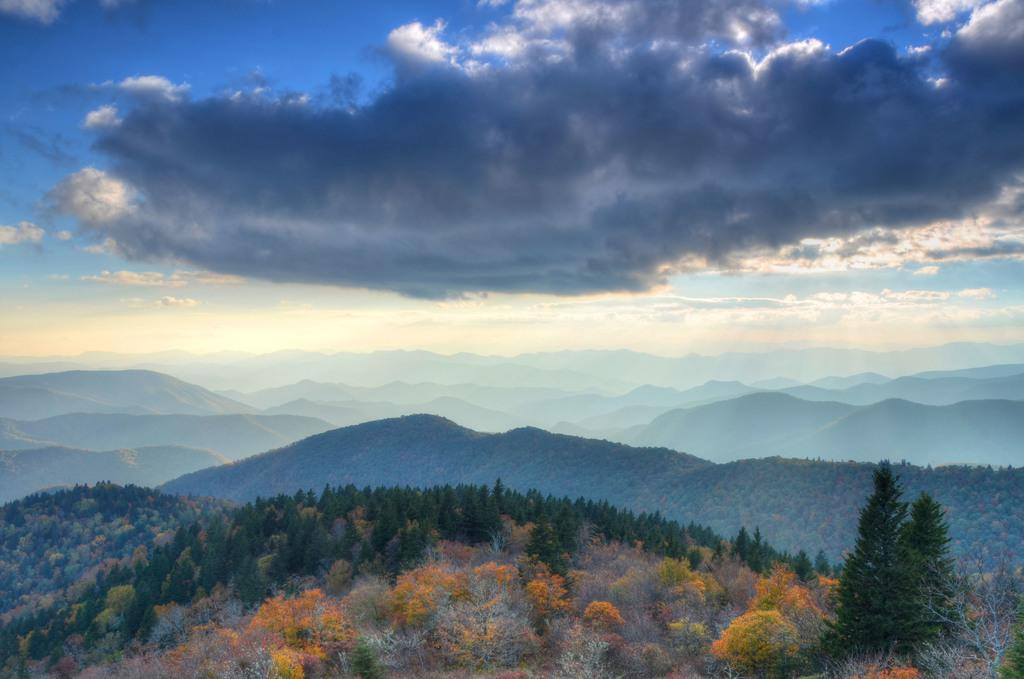What type of vegetation is present at the bottom of the image? There are many trees at the bottom of the image. What geographical features can be seen in the background of the image? Hills are visible in the background of the image. What is the condition of the sky in the background of the image? The sky is cloudy in the background of the image. How much wealth is represented by the trees in the image? The image does not convey any information about wealth, as it only shows trees and hills. What type of friction can be observed between the trees and the hills in the image? There is no indication of friction between the trees and the hills in the image, as it is a static representation. 